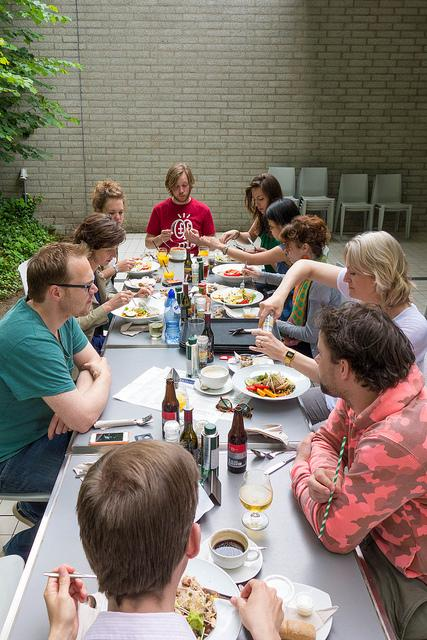Why does the person with the green shirt have no food?

Choices:
A) is through
B) is confused
C) is dieting
D) is sharing is sharing 